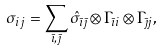Convert formula to latex. <formula><loc_0><loc_0><loc_500><loc_500>\sigma _ { i j } & = \sum _ { \bar { \imath } , \bar { \jmath } } \hat { \sigma } _ { \bar { \imath } \bar { \jmath } } \otimes \Gamma _ { \bar { \imath } { i } } \otimes \Gamma _ { \bar { \jmath } { j } } ,</formula> 